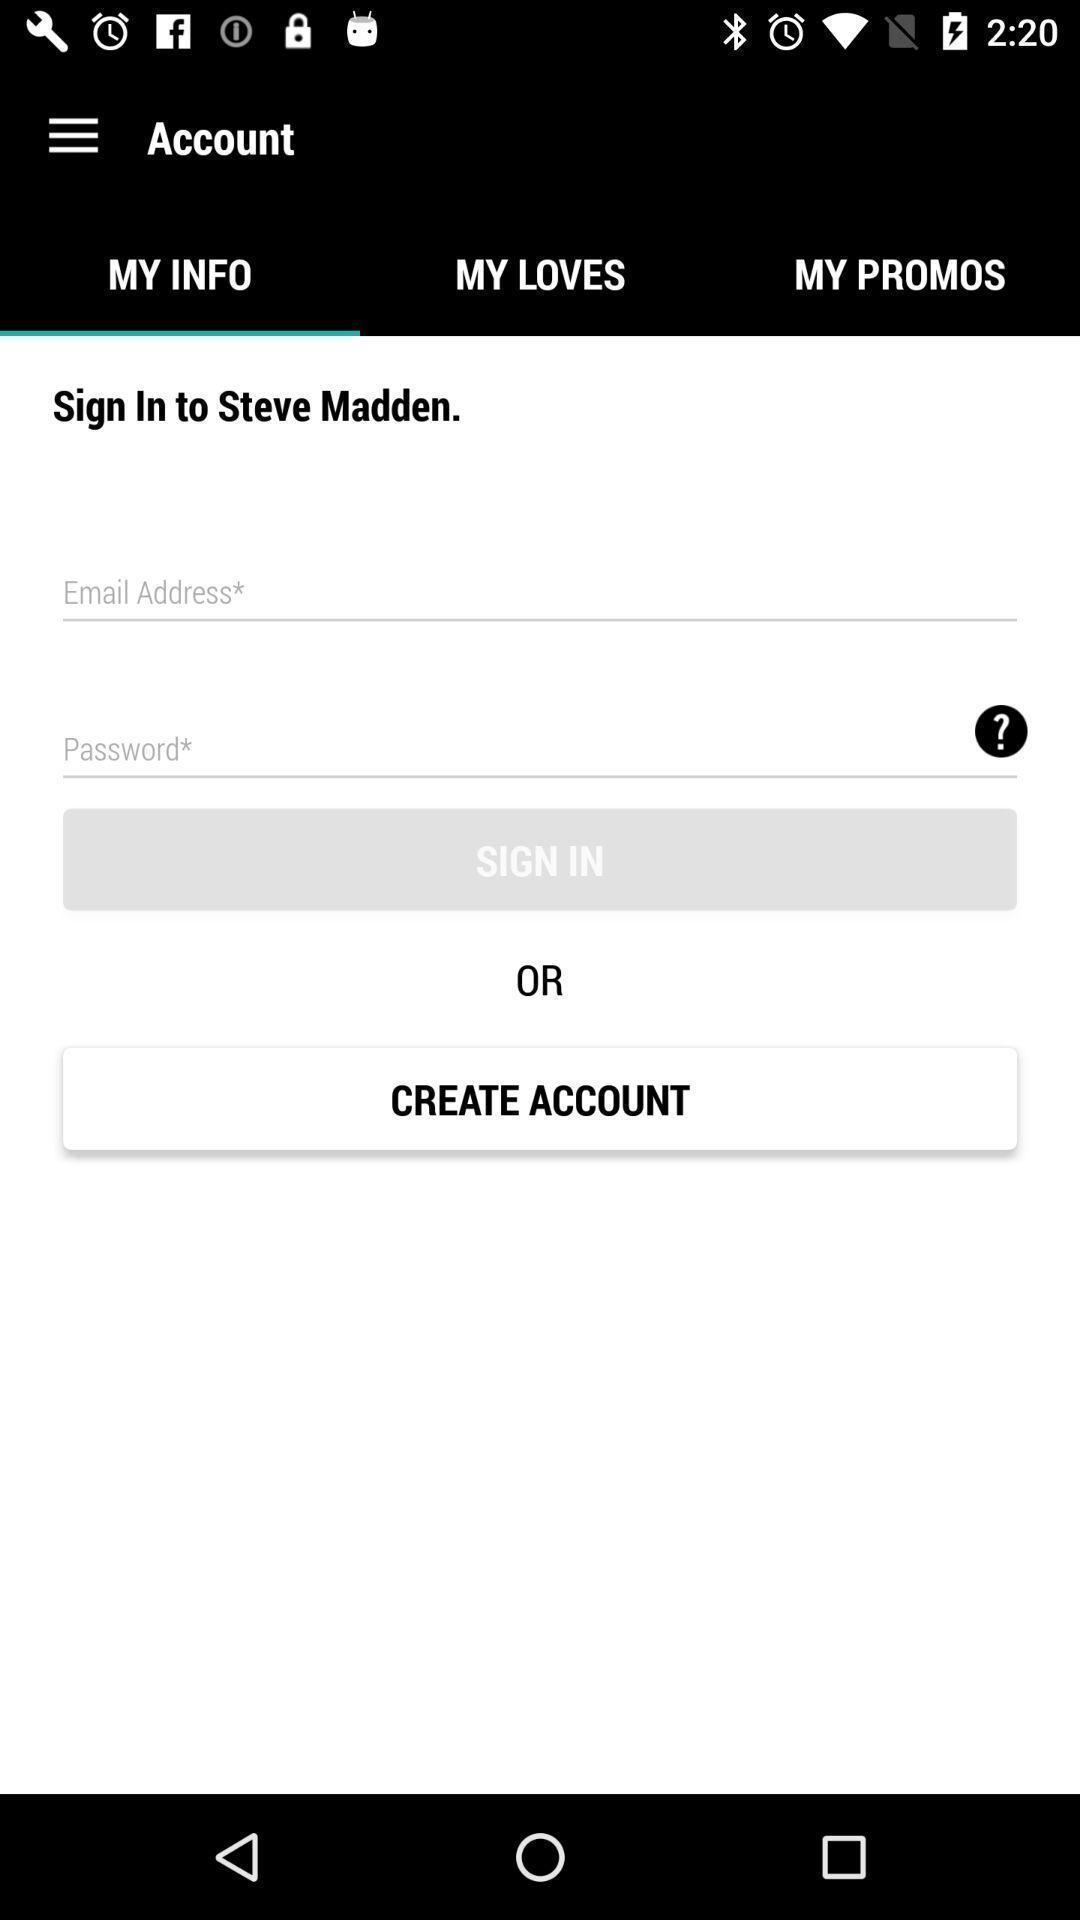Explain what's happening in this screen capture. Sign in page displayed. 